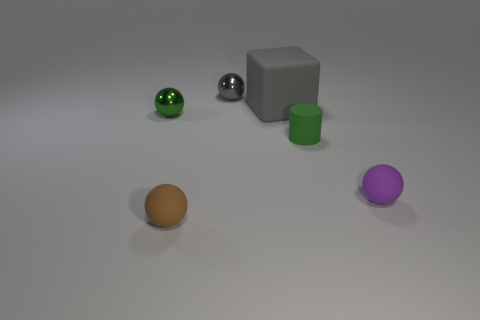Subtract all purple matte balls. How many balls are left? 3 Add 2 gray objects. How many objects exist? 8 Subtract 1 cylinders. How many cylinders are left? 0 Subtract all brown balls. How many balls are left? 3 Subtract all blue cylinders. How many yellow spheres are left? 0 Subtract all large yellow spheres. Subtract all tiny purple objects. How many objects are left? 5 Add 4 rubber balls. How many rubber balls are left? 6 Add 1 big gray matte blocks. How many big gray matte blocks exist? 2 Subtract 0 blue blocks. How many objects are left? 6 Subtract all cubes. How many objects are left? 5 